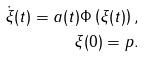<formula> <loc_0><loc_0><loc_500><loc_500>\dot { \xi } ( t ) = a ( t ) \Phi \left ( \xi ( t ) \right ) , \\ \xi ( 0 ) = p .</formula> 